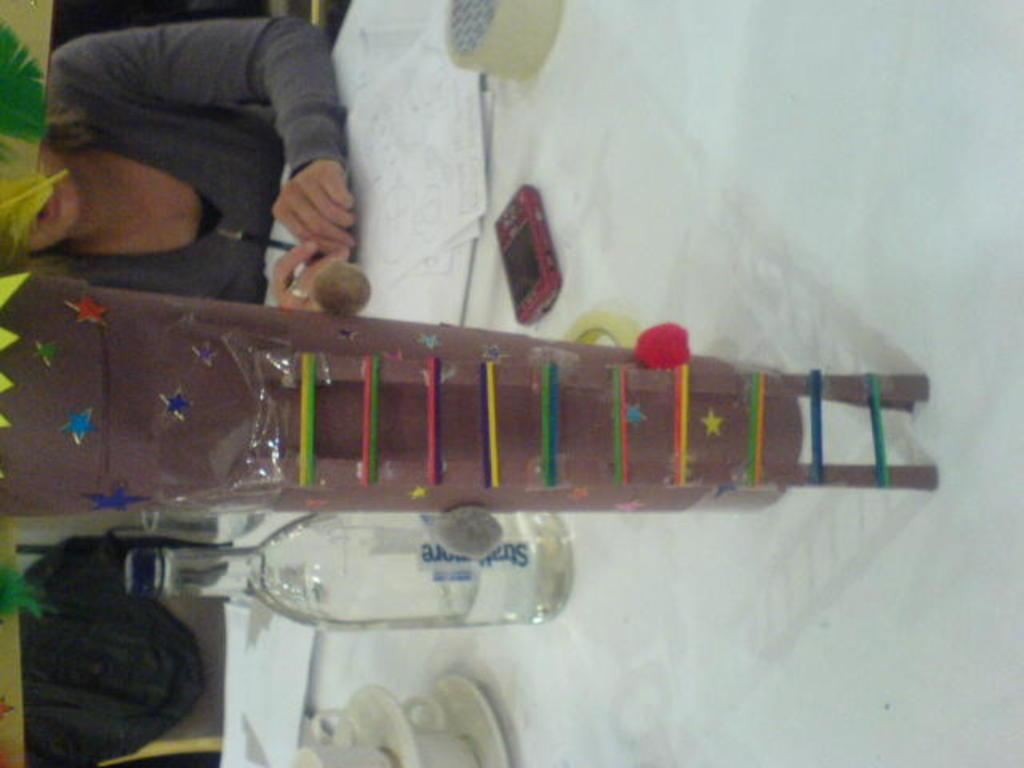What is located on the right side of the image? There is a table on the right side of the image. What items can be seen on the table? There are bottles, a mobile phone, and papers on the table. What else is visible in the image besides the table and its contents? There are products visible in the image. Can you describe the person in the image? There is a person sitting behind the table. What type of meat is being served on the table in the image? There is no meat present in the image; it features a table with bottles, a mobile phone, papers, and products. 